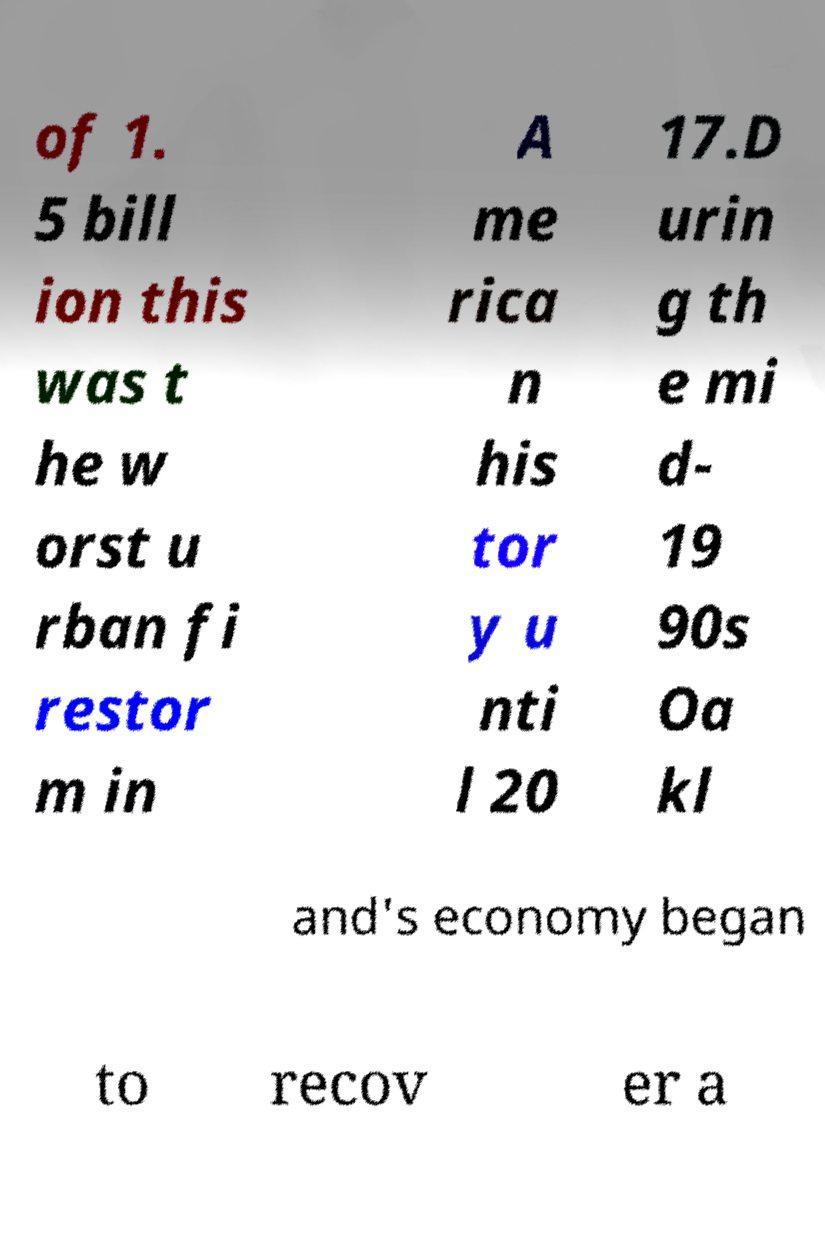What messages or text are displayed in this image? I need them in a readable, typed format. of 1. 5 bill ion this was t he w orst u rban fi restor m in A me rica n his tor y u nti l 20 17.D urin g th e mi d- 19 90s Oa kl and's economy began to recov er a 